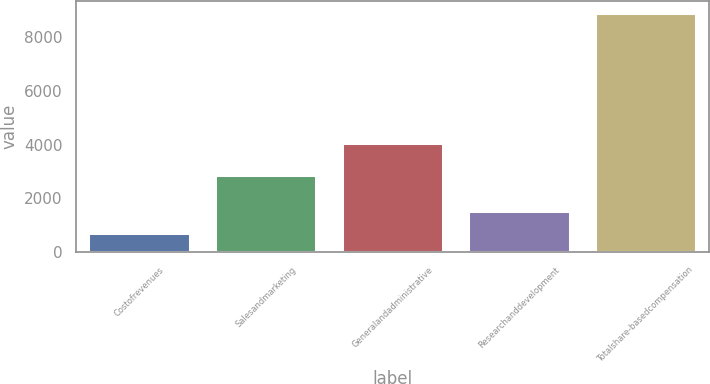Convert chart. <chart><loc_0><loc_0><loc_500><loc_500><bar_chart><fcel>Costofrevenues<fcel>Salesandmarketing<fcel>Generalandadministrative<fcel>Researchanddevelopment<fcel>Totalshare-basedcompensation<nl><fcel>700<fcel>2862<fcel>4054<fcel>1521<fcel>8910<nl></chart> 